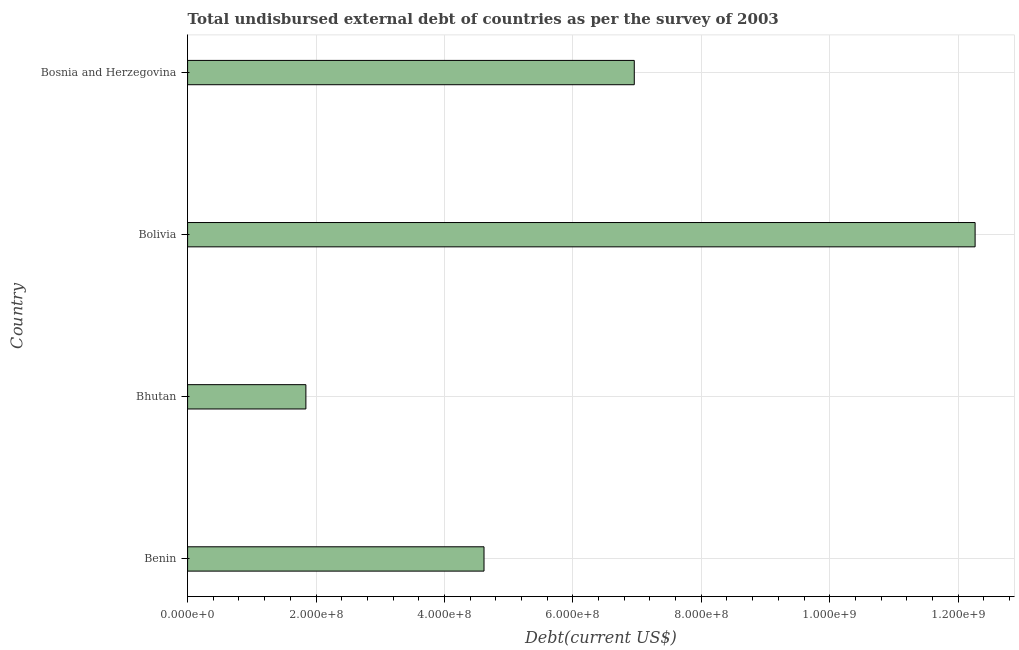Does the graph contain any zero values?
Your response must be concise. No. What is the title of the graph?
Keep it short and to the point. Total undisbursed external debt of countries as per the survey of 2003. What is the label or title of the X-axis?
Ensure brevity in your answer.  Debt(current US$). What is the total debt in Benin?
Make the answer very short. 4.62e+08. Across all countries, what is the maximum total debt?
Offer a very short reply. 1.23e+09. Across all countries, what is the minimum total debt?
Provide a succinct answer. 1.84e+08. In which country was the total debt minimum?
Ensure brevity in your answer.  Bhutan. What is the sum of the total debt?
Your answer should be compact. 2.57e+09. What is the difference between the total debt in Bhutan and Bolivia?
Offer a terse response. -1.04e+09. What is the average total debt per country?
Offer a very short reply. 6.42e+08. What is the median total debt?
Provide a succinct answer. 5.79e+08. In how many countries, is the total debt greater than 1160000000 US$?
Offer a terse response. 1. What is the ratio of the total debt in Bhutan to that in Bolivia?
Give a very brief answer. 0.15. Is the difference between the total debt in Benin and Bosnia and Herzegovina greater than the difference between any two countries?
Offer a very short reply. No. What is the difference between the highest and the second highest total debt?
Your response must be concise. 5.31e+08. What is the difference between the highest and the lowest total debt?
Provide a succinct answer. 1.04e+09. In how many countries, is the total debt greater than the average total debt taken over all countries?
Your answer should be compact. 2. How many bars are there?
Provide a succinct answer. 4. What is the Debt(current US$) in Benin?
Offer a terse response. 4.62e+08. What is the Debt(current US$) of Bhutan?
Give a very brief answer. 1.84e+08. What is the Debt(current US$) in Bolivia?
Provide a succinct answer. 1.23e+09. What is the Debt(current US$) of Bosnia and Herzegovina?
Your answer should be very brief. 6.96e+08. What is the difference between the Debt(current US$) in Benin and Bhutan?
Offer a terse response. 2.77e+08. What is the difference between the Debt(current US$) in Benin and Bolivia?
Keep it short and to the point. -7.65e+08. What is the difference between the Debt(current US$) in Benin and Bosnia and Herzegovina?
Provide a succinct answer. -2.34e+08. What is the difference between the Debt(current US$) in Bhutan and Bolivia?
Provide a short and direct response. -1.04e+09. What is the difference between the Debt(current US$) in Bhutan and Bosnia and Herzegovina?
Offer a very short reply. -5.11e+08. What is the difference between the Debt(current US$) in Bolivia and Bosnia and Herzegovina?
Provide a succinct answer. 5.31e+08. What is the ratio of the Debt(current US$) in Benin to that in Bhutan?
Keep it short and to the point. 2.51. What is the ratio of the Debt(current US$) in Benin to that in Bolivia?
Your answer should be very brief. 0.38. What is the ratio of the Debt(current US$) in Benin to that in Bosnia and Herzegovina?
Keep it short and to the point. 0.66. What is the ratio of the Debt(current US$) in Bhutan to that in Bosnia and Herzegovina?
Give a very brief answer. 0.27. What is the ratio of the Debt(current US$) in Bolivia to that in Bosnia and Herzegovina?
Give a very brief answer. 1.76. 